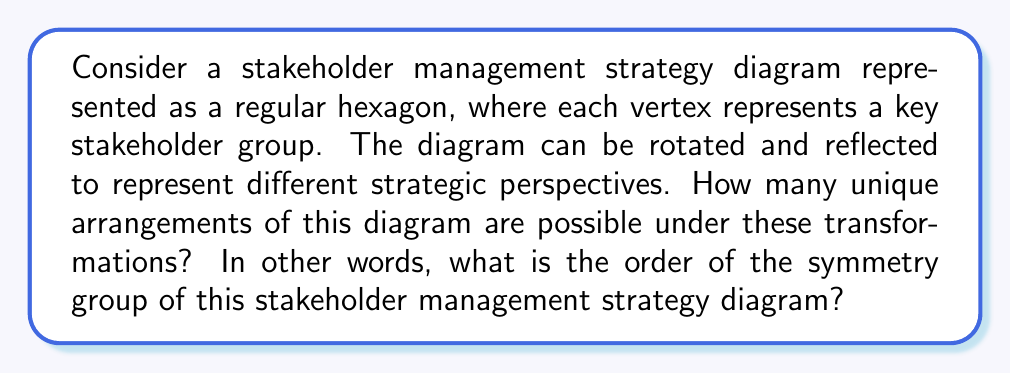Teach me how to tackle this problem. To solve this problem, we need to analyze the symmetry group of a regular hexagon. Let's approach this step-by-step:

1) A regular hexagon has two types of symmetries:
   a) Rotational symmetries
   b) Reflection symmetries

2) Rotational symmetries:
   - A regular hexagon can be rotated by multiples of 60° (or π/3 radians) to coincide with itself.
   - There are 6 rotational symmetries: 0°, 60°, 120°, 180°, 240°, 300°

3) Reflection symmetries:
   - A regular hexagon has 6 lines of reflection:
     - 3 passing through opposite vertices
     - 3 passing through the midpoints of opposite sides

4) The symmetry group of a regular hexagon is known as the dihedral group D6.

5) The order of the symmetry group is the total number of symmetries:
   - Number of rotational symmetries: 6
   - Number of reflection symmetries: 6
   - Total: 6 + 6 = 12

6) Therefore, the order of the symmetry group D6 is 12.

In the context of stakeholder management, this means there are 12 unique ways to arrange or view the stakeholder diagram, each potentially offering a different strategic perspective on stakeholder relationships and priorities.
Answer: The order of the symmetry group of the stakeholder management strategy diagram (represented as a regular hexagon) is 12. 